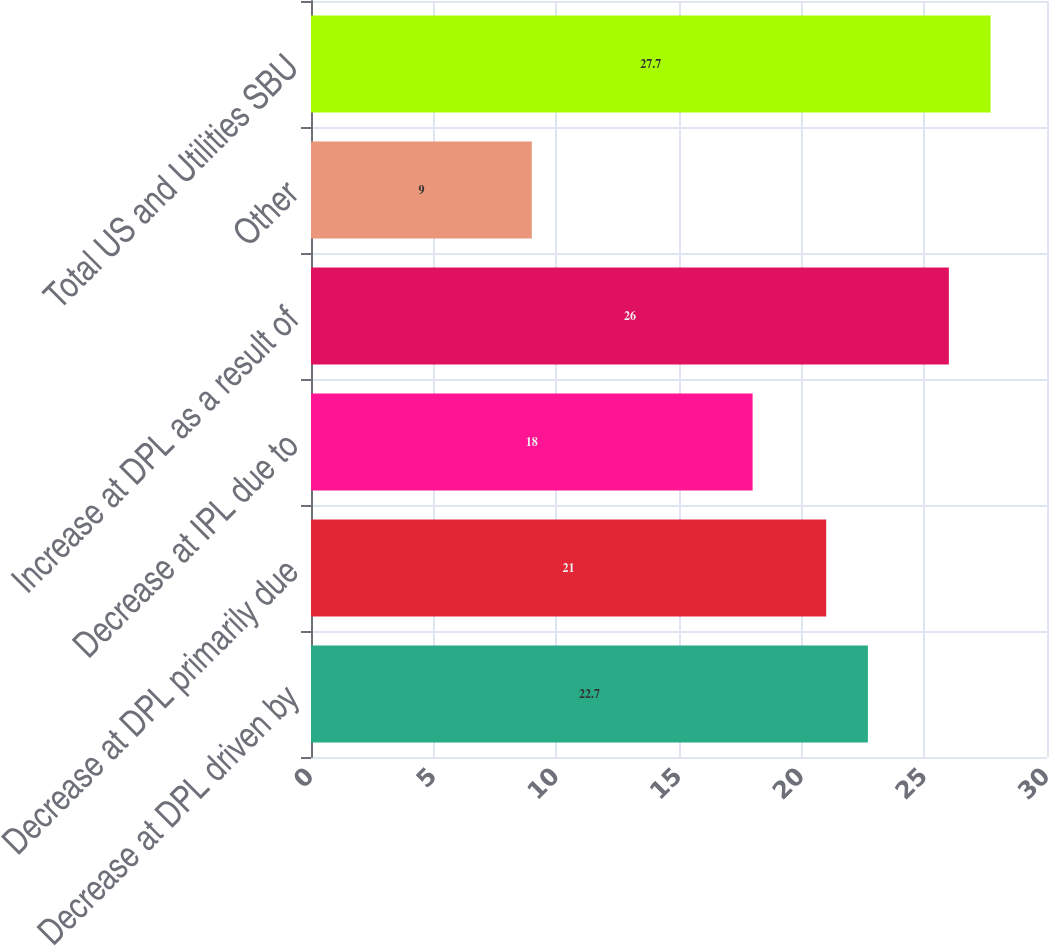Convert chart. <chart><loc_0><loc_0><loc_500><loc_500><bar_chart><fcel>Decrease at DPL driven by<fcel>Decrease at DPL primarily due<fcel>Decrease at IPL due to<fcel>Increase at DPL as a result of<fcel>Other<fcel>Total US and Utilities SBU<nl><fcel>22.7<fcel>21<fcel>18<fcel>26<fcel>9<fcel>27.7<nl></chart> 